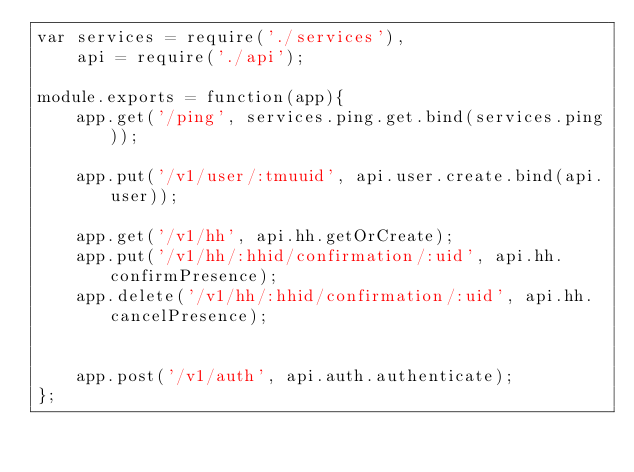<code> <loc_0><loc_0><loc_500><loc_500><_JavaScript_>var services = require('./services'),
	api = require('./api');

module.exports = function(app){
	app.get('/ping', services.ping.get.bind(services.ping));

	app.put('/v1/user/:tmuuid', api.user.create.bind(api.user));

	app.get('/v1/hh', api.hh.getOrCreate);
	app.put('/v1/hh/:hhid/confirmation/:uid', api.hh.confirmPresence);
	app.delete('/v1/hh/:hhid/confirmation/:uid', api.hh.cancelPresence);


	app.post('/v1/auth', api.auth.authenticate);
};</code> 